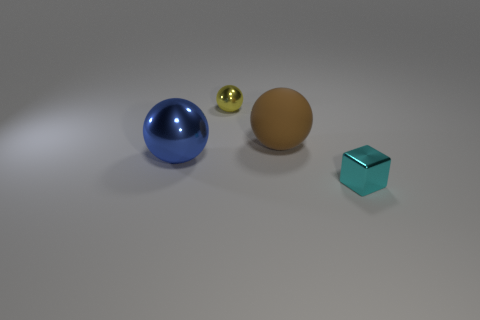Add 4 brown balls. How many objects exist? 8 Subtract all cubes. How many objects are left? 3 Add 2 small purple metal blocks. How many small purple metal blocks exist? 2 Subtract 1 brown spheres. How many objects are left? 3 Subtract all brown metal objects. Subtract all small yellow things. How many objects are left? 3 Add 4 small shiny cubes. How many small shiny cubes are left? 5 